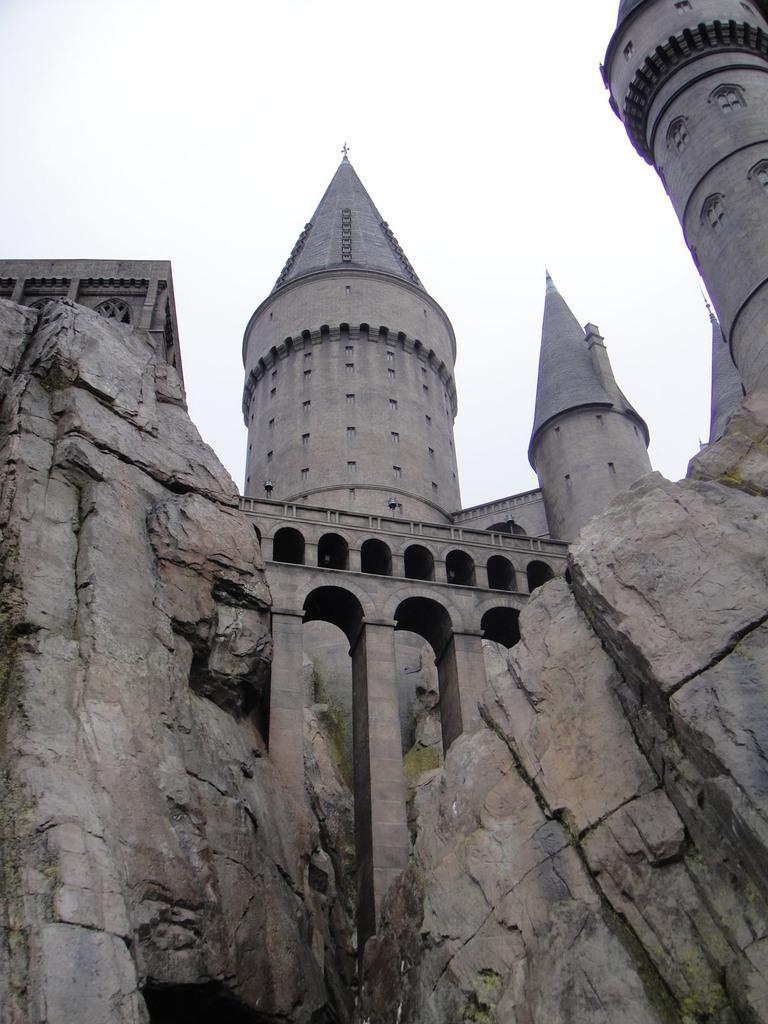Describe this image in one or two sentences. In this image there is a fort. In the foreground there are rocks. There is a bridge across the rock. At the top there is the sky. There is algae on the rocks. 